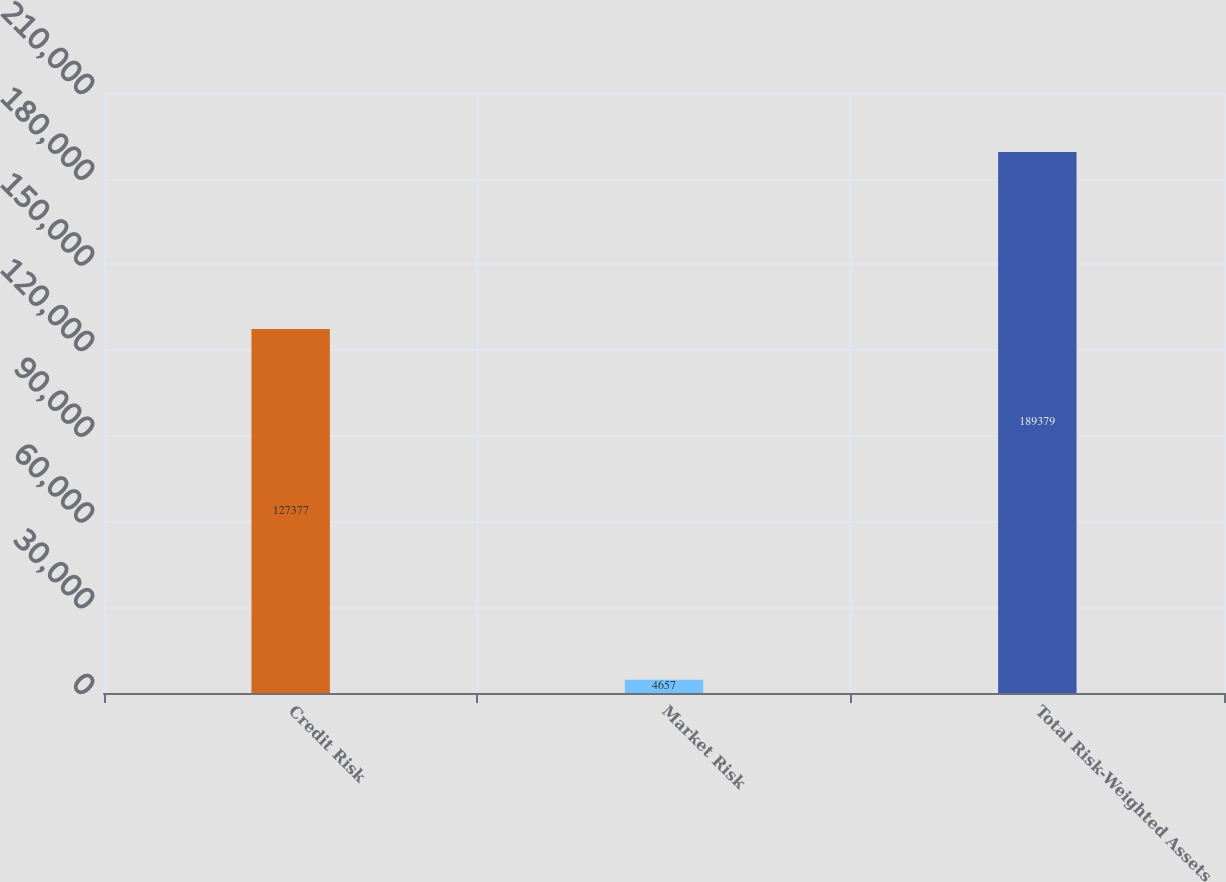<chart> <loc_0><loc_0><loc_500><loc_500><bar_chart><fcel>Credit Risk<fcel>Market Risk<fcel>Total Risk-Weighted Assets<nl><fcel>127377<fcel>4657<fcel>189379<nl></chart> 